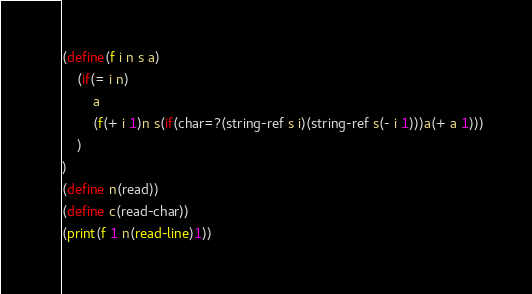Convert code to text. <code><loc_0><loc_0><loc_500><loc_500><_Scheme_>(define(f i n s a)
	(if(= i n)
		a
		(f(+ i 1)n s(if(char=?(string-ref s i)(string-ref s(- i 1)))a(+ a 1)))
	)
)
(define n(read))
(define c(read-char))
(print(f 1 n(read-line)1))</code> 